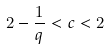Convert formula to latex. <formula><loc_0><loc_0><loc_500><loc_500>2 - \frac { 1 } { q } < c < 2</formula> 